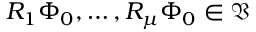<formula> <loc_0><loc_0><loc_500><loc_500>R _ { 1 } \Phi _ { 0 } , \dots , R _ { \mu } \Phi _ { 0 } \in \mathfrak { V }</formula> 